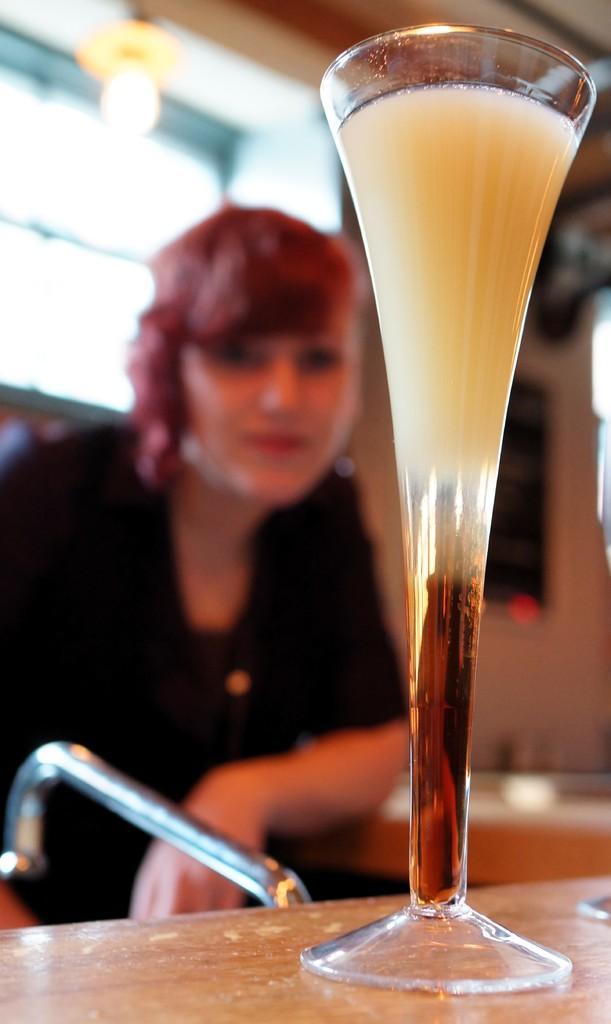Could you give a brief overview of what you see in this image? In this image we can see a person sitting on the seating stool and a table is placed in front of her. On the table we can see a beverage glass. 